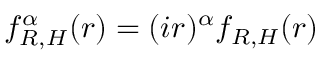Convert formula to latex. <formula><loc_0><loc_0><loc_500><loc_500>f _ { R , H } ^ { \alpha } ( r ) = ( i r ) ^ { \alpha } f _ { R , H } ( r )</formula> 